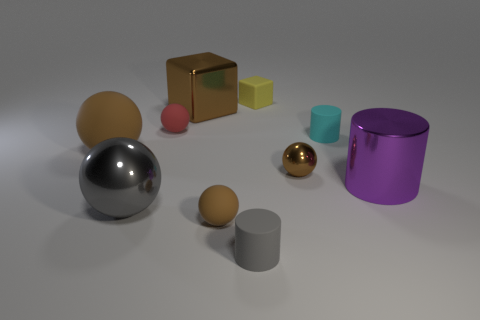How many brown balls must be subtracted to get 1 brown balls? 2 Subtract all red blocks. How many brown spheres are left? 3 Subtract 1 balls. How many balls are left? 4 Subtract all gray balls. How many balls are left? 4 Subtract all red spheres. How many spheres are left? 4 Subtract all red spheres. Subtract all brown blocks. How many spheres are left? 4 Subtract all blocks. How many objects are left? 8 Subtract all purple shiny objects. Subtract all purple matte cubes. How many objects are left? 9 Add 6 gray cylinders. How many gray cylinders are left? 7 Add 3 large yellow metallic spheres. How many large yellow metallic spheres exist? 3 